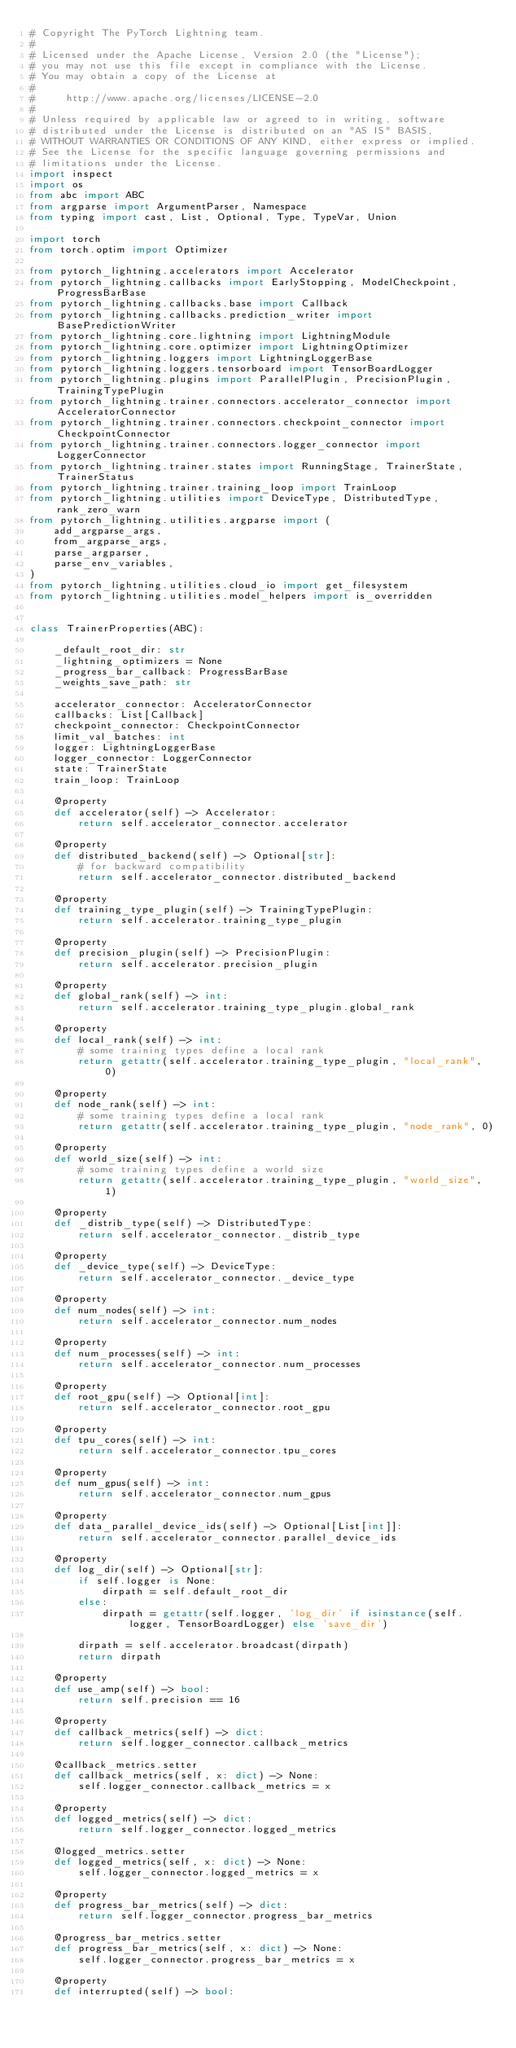Convert code to text. <code><loc_0><loc_0><loc_500><loc_500><_Python_># Copyright The PyTorch Lightning team.
#
# Licensed under the Apache License, Version 2.0 (the "License");
# you may not use this file except in compliance with the License.
# You may obtain a copy of the License at
#
#     http://www.apache.org/licenses/LICENSE-2.0
#
# Unless required by applicable law or agreed to in writing, software
# distributed under the License is distributed on an "AS IS" BASIS,
# WITHOUT WARRANTIES OR CONDITIONS OF ANY KIND, either express or implied.
# See the License for the specific language governing permissions and
# limitations under the License.
import inspect
import os
from abc import ABC
from argparse import ArgumentParser, Namespace
from typing import cast, List, Optional, Type, TypeVar, Union

import torch
from torch.optim import Optimizer

from pytorch_lightning.accelerators import Accelerator
from pytorch_lightning.callbacks import EarlyStopping, ModelCheckpoint, ProgressBarBase
from pytorch_lightning.callbacks.base import Callback
from pytorch_lightning.callbacks.prediction_writer import BasePredictionWriter
from pytorch_lightning.core.lightning import LightningModule
from pytorch_lightning.core.optimizer import LightningOptimizer
from pytorch_lightning.loggers import LightningLoggerBase
from pytorch_lightning.loggers.tensorboard import TensorBoardLogger
from pytorch_lightning.plugins import ParallelPlugin, PrecisionPlugin, TrainingTypePlugin
from pytorch_lightning.trainer.connectors.accelerator_connector import AcceleratorConnector
from pytorch_lightning.trainer.connectors.checkpoint_connector import CheckpointConnector
from pytorch_lightning.trainer.connectors.logger_connector import LoggerConnector
from pytorch_lightning.trainer.states import RunningStage, TrainerState, TrainerStatus
from pytorch_lightning.trainer.training_loop import TrainLoop
from pytorch_lightning.utilities import DeviceType, DistributedType, rank_zero_warn
from pytorch_lightning.utilities.argparse import (
    add_argparse_args,
    from_argparse_args,
    parse_argparser,
    parse_env_variables,
)
from pytorch_lightning.utilities.cloud_io import get_filesystem
from pytorch_lightning.utilities.model_helpers import is_overridden


class TrainerProperties(ABC):

    _default_root_dir: str
    _lightning_optimizers = None
    _progress_bar_callback: ProgressBarBase
    _weights_save_path: str

    accelerator_connector: AcceleratorConnector
    callbacks: List[Callback]
    checkpoint_connector: CheckpointConnector
    limit_val_batches: int
    logger: LightningLoggerBase
    logger_connector: LoggerConnector
    state: TrainerState
    train_loop: TrainLoop

    @property
    def accelerator(self) -> Accelerator:
        return self.accelerator_connector.accelerator

    @property
    def distributed_backend(self) -> Optional[str]:
        # for backward compatibility
        return self.accelerator_connector.distributed_backend

    @property
    def training_type_plugin(self) -> TrainingTypePlugin:
        return self.accelerator.training_type_plugin

    @property
    def precision_plugin(self) -> PrecisionPlugin:
        return self.accelerator.precision_plugin

    @property
    def global_rank(self) -> int:
        return self.accelerator.training_type_plugin.global_rank

    @property
    def local_rank(self) -> int:
        # some training types define a local rank
        return getattr(self.accelerator.training_type_plugin, "local_rank", 0)

    @property
    def node_rank(self) -> int:
        # some training types define a local rank
        return getattr(self.accelerator.training_type_plugin, "node_rank", 0)

    @property
    def world_size(self) -> int:
        # some training types define a world size
        return getattr(self.accelerator.training_type_plugin, "world_size", 1)

    @property
    def _distrib_type(self) -> DistributedType:
        return self.accelerator_connector._distrib_type

    @property
    def _device_type(self) -> DeviceType:
        return self.accelerator_connector._device_type

    @property
    def num_nodes(self) -> int:
        return self.accelerator_connector.num_nodes

    @property
    def num_processes(self) -> int:
        return self.accelerator_connector.num_processes

    @property
    def root_gpu(self) -> Optional[int]:
        return self.accelerator_connector.root_gpu

    @property
    def tpu_cores(self) -> int:
        return self.accelerator_connector.tpu_cores

    @property
    def num_gpus(self) -> int:
        return self.accelerator_connector.num_gpus

    @property
    def data_parallel_device_ids(self) -> Optional[List[int]]:
        return self.accelerator_connector.parallel_device_ids

    @property
    def log_dir(self) -> Optional[str]:
        if self.logger is None:
            dirpath = self.default_root_dir
        else:
            dirpath = getattr(self.logger, 'log_dir' if isinstance(self.logger, TensorBoardLogger) else 'save_dir')

        dirpath = self.accelerator.broadcast(dirpath)
        return dirpath

    @property
    def use_amp(self) -> bool:
        return self.precision == 16

    @property
    def callback_metrics(self) -> dict:
        return self.logger_connector.callback_metrics

    @callback_metrics.setter
    def callback_metrics(self, x: dict) -> None:
        self.logger_connector.callback_metrics = x

    @property
    def logged_metrics(self) -> dict:
        return self.logger_connector.logged_metrics

    @logged_metrics.setter
    def logged_metrics(self, x: dict) -> None:
        self.logger_connector.logged_metrics = x

    @property
    def progress_bar_metrics(self) -> dict:
        return self.logger_connector.progress_bar_metrics

    @progress_bar_metrics.setter
    def progress_bar_metrics(self, x: dict) -> None:
        self.logger_connector.progress_bar_metrics = x

    @property
    def interrupted(self) -> bool:</code> 